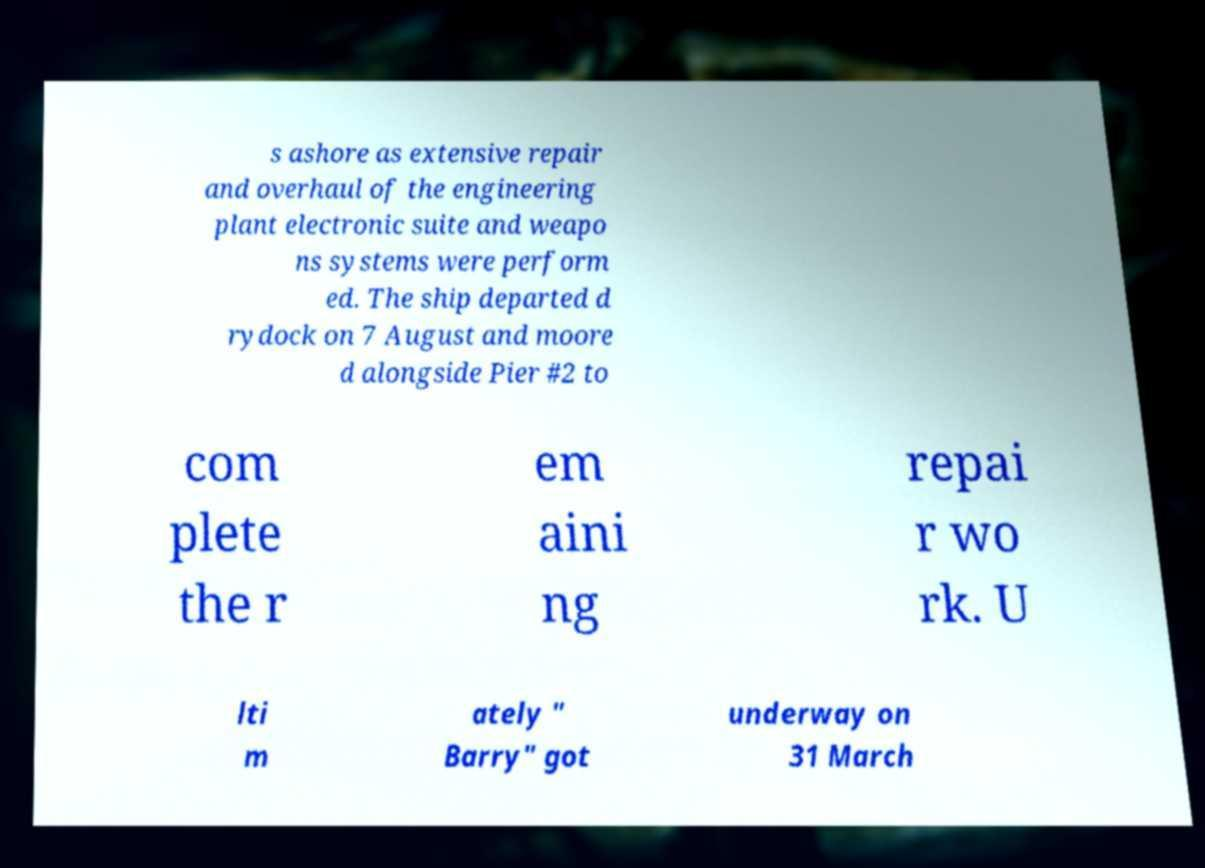Please identify and transcribe the text found in this image. s ashore as extensive repair and overhaul of the engineering plant electronic suite and weapo ns systems were perform ed. The ship departed d rydock on 7 August and moore d alongside Pier #2 to com plete the r em aini ng repai r wo rk. U lti m ately " Barry" got underway on 31 March 